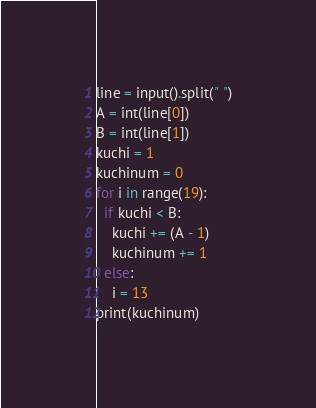<code> <loc_0><loc_0><loc_500><loc_500><_Python_>line = input().split(" ")
A = int(line[0])
B = int(line[1])
kuchi = 1
kuchinum = 0
for i in range(19):
  if kuchi < B:
    kuchi += (A - 1)
    kuchinum += 1
  else:
    i = 13
print(kuchinum)</code> 